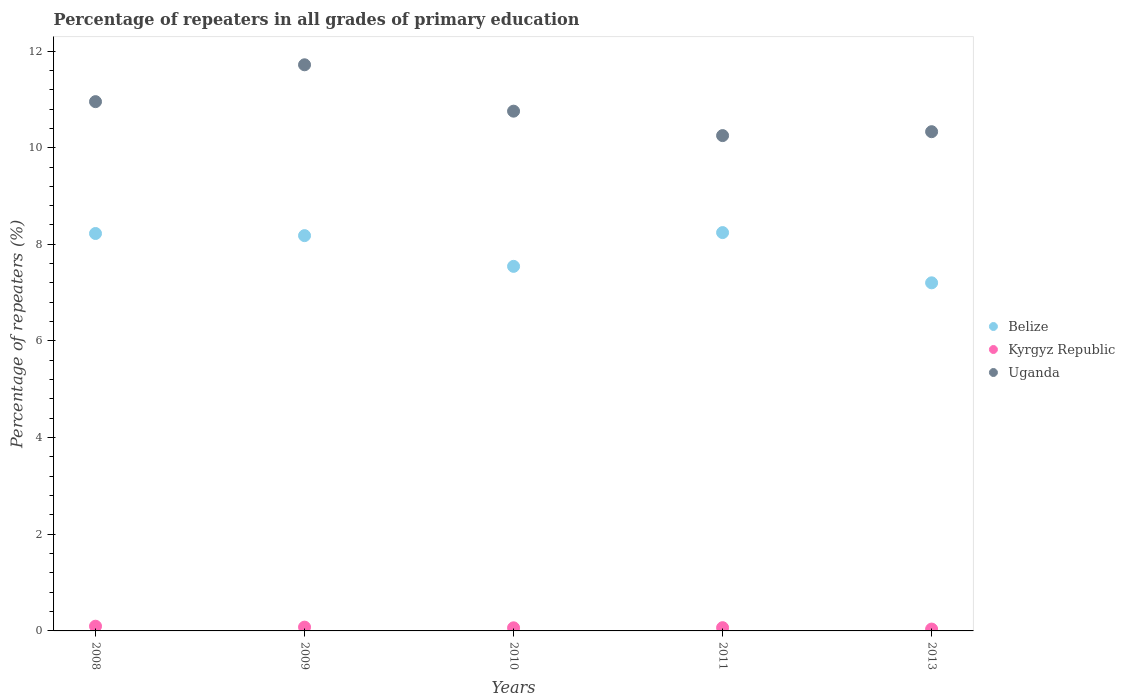How many different coloured dotlines are there?
Ensure brevity in your answer.  3. What is the percentage of repeaters in Belize in 2013?
Ensure brevity in your answer.  7.2. Across all years, what is the maximum percentage of repeaters in Kyrgyz Republic?
Your response must be concise. 0.1. Across all years, what is the minimum percentage of repeaters in Uganda?
Your answer should be very brief. 10.25. In which year was the percentage of repeaters in Belize minimum?
Your answer should be compact. 2013. What is the total percentage of repeaters in Kyrgyz Republic in the graph?
Give a very brief answer. 0.35. What is the difference between the percentage of repeaters in Uganda in 2008 and that in 2013?
Provide a succinct answer. 0.62. What is the difference between the percentage of repeaters in Belize in 2011 and the percentage of repeaters in Uganda in 2009?
Offer a very short reply. -3.47. What is the average percentage of repeaters in Uganda per year?
Offer a terse response. 10.8. In the year 2011, what is the difference between the percentage of repeaters in Belize and percentage of repeaters in Kyrgyz Republic?
Give a very brief answer. 8.18. In how many years, is the percentage of repeaters in Belize greater than 10 %?
Keep it short and to the point. 0. What is the ratio of the percentage of repeaters in Kyrgyz Republic in 2008 to that in 2009?
Ensure brevity in your answer.  1.24. What is the difference between the highest and the second highest percentage of repeaters in Kyrgyz Republic?
Provide a succinct answer. 0.02. What is the difference between the highest and the lowest percentage of repeaters in Kyrgyz Republic?
Your answer should be compact. 0.06. Does the percentage of repeaters in Kyrgyz Republic monotonically increase over the years?
Give a very brief answer. No. Is the percentage of repeaters in Uganda strictly less than the percentage of repeaters in Belize over the years?
Provide a succinct answer. No. How many dotlines are there?
Offer a very short reply. 3. How many years are there in the graph?
Provide a succinct answer. 5. What is the difference between two consecutive major ticks on the Y-axis?
Your answer should be compact. 2. Are the values on the major ticks of Y-axis written in scientific E-notation?
Give a very brief answer. No. Does the graph contain any zero values?
Ensure brevity in your answer.  No. Does the graph contain grids?
Ensure brevity in your answer.  No. How many legend labels are there?
Your answer should be very brief. 3. What is the title of the graph?
Make the answer very short. Percentage of repeaters in all grades of primary education. What is the label or title of the X-axis?
Your response must be concise. Years. What is the label or title of the Y-axis?
Ensure brevity in your answer.  Percentage of repeaters (%). What is the Percentage of repeaters (%) of Belize in 2008?
Provide a succinct answer. 8.22. What is the Percentage of repeaters (%) of Kyrgyz Republic in 2008?
Ensure brevity in your answer.  0.1. What is the Percentage of repeaters (%) in Uganda in 2008?
Your answer should be very brief. 10.95. What is the Percentage of repeaters (%) of Belize in 2009?
Give a very brief answer. 8.18. What is the Percentage of repeaters (%) in Kyrgyz Republic in 2009?
Offer a terse response. 0.08. What is the Percentage of repeaters (%) in Uganda in 2009?
Offer a very short reply. 11.72. What is the Percentage of repeaters (%) of Belize in 2010?
Ensure brevity in your answer.  7.54. What is the Percentage of repeaters (%) in Kyrgyz Republic in 2010?
Give a very brief answer. 0.06. What is the Percentage of repeaters (%) in Uganda in 2010?
Your answer should be very brief. 10.76. What is the Percentage of repeaters (%) of Belize in 2011?
Your response must be concise. 8.24. What is the Percentage of repeaters (%) in Kyrgyz Republic in 2011?
Make the answer very short. 0.07. What is the Percentage of repeaters (%) of Uganda in 2011?
Give a very brief answer. 10.25. What is the Percentage of repeaters (%) of Belize in 2013?
Make the answer very short. 7.2. What is the Percentage of repeaters (%) of Kyrgyz Republic in 2013?
Your response must be concise. 0.04. What is the Percentage of repeaters (%) in Uganda in 2013?
Make the answer very short. 10.33. Across all years, what is the maximum Percentage of repeaters (%) in Belize?
Offer a very short reply. 8.24. Across all years, what is the maximum Percentage of repeaters (%) in Kyrgyz Republic?
Your answer should be compact. 0.1. Across all years, what is the maximum Percentage of repeaters (%) in Uganda?
Provide a short and direct response. 11.72. Across all years, what is the minimum Percentage of repeaters (%) in Belize?
Provide a short and direct response. 7.2. Across all years, what is the minimum Percentage of repeaters (%) of Kyrgyz Republic?
Keep it short and to the point. 0.04. Across all years, what is the minimum Percentage of repeaters (%) of Uganda?
Give a very brief answer. 10.25. What is the total Percentage of repeaters (%) in Belize in the graph?
Provide a succinct answer. 39.39. What is the total Percentage of repeaters (%) of Kyrgyz Republic in the graph?
Offer a very short reply. 0.35. What is the total Percentage of repeaters (%) of Uganda in the graph?
Your response must be concise. 54. What is the difference between the Percentage of repeaters (%) of Belize in 2008 and that in 2009?
Your response must be concise. 0.04. What is the difference between the Percentage of repeaters (%) in Kyrgyz Republic in 2008 and that in 2009?
Keep it short and to the point. 0.02. What is the difference between the Percentage of repeaters (%) of Uganda in 2008 and that in 2009?
Your answer should be very brief. -0.76. What is the difference between the Percentage of repeaters (%) in Belize in 2008 and that in 2010?
Give a very brief answer. 0.68. What is the difference between the Percentage of repeaters (%) of Uganda in 2008 and that in 2010?
Provide a succinct answer. 0.2. What is the difference between the Percentage of repeaters (%) in Belize in 2008 and that in 2011?
Offer a terse response. -0.02. What is the difference between the Percentage of repeaters (%) in Kyrgyz Republic in 2008 and that in 2011?
Your answer should be compact. 0.03. What is the difference between the Percentage of repeaters (%) of Uganda in 2008 and that in 2011?
Your answer should be very brief. 0.7. What is the difference between the Percentage of repeaters (%) of Belize in 2008 and that in 2013?
Offer a terse response. 1.02. What is the difference between the Percentage of repeaters (%) in Kyrgyz Republic in 2008 and that in 2013?
Your answer should be compact. 0.06. What is the difference between the Percentage of repeaters (%) in Uganda in 2008 and that in 2013?
Your response must be concise. 0.62. What is the difference between the Percentage of repeaters (%) of Belize in 2009 and that in 2010?
Your answer should be compact. 0.64. What is the difference between the Percentage of repeaters (%) in Kyrgyz Republic in 2009 and that in 2010?
Offer a very short reply. 0.01. What is the difference between the Percentage of repeaters (%) of Uganda in 2009 and that in 2010?
Keep it short and to the point. 0.96. What is the difference between the Percentage of repeaters (%) in Belize in 2009 and that in 2011?
Offer a very short reply. -0.06. What is the difference between the Percentage of repeaters (%) of Kyrgyz Republic in 2009 and that in 2011?
Provide a succinct answer. 0.01. What is the difference between the Percentage of repeaters (%) in Uganda in 2009 and that in 2011?
Your response must be concise. 1.47. What is the difference between the Percentage of repeaters (%) in Belize in 2009 and that in 2013?
Your answer should be very brief. 0.98. What is the difference between the Percentage of repeaters (%) of Uganda in 2009 and that in 2013?
Offer a very short reply. 1.38. What is the difference between the Percentage of repeaters (%) in Belize in 2010 and that in 2011?
Your response must be concise. -0.7. What is the difference between the Percentage of repeaters (%) of Kyrgyz Republic in 2010 and that in 2011?
Your response must be concise. -0. What is the difference between the Percentage of repeaters (%) of Uganda in 2010 and that in 2011?
Provide a succinct answer. 0.51. What is the difference between the Percentage of repeaters (%) in Belize in 2010 and that in 2013?
Your answer should be very brief. 0.34. What is the difference between the Percentage of repeaters (%) of Kyrgyz Republic in 2010 and that in 2013?
Your response must be concise. 0.03. What is the difference between the Percentage of repeaters (%) of Uganda in 2010 and that in 2013?
Give a very brief answer. 0.42. What is the difference between the Percentage of repeaters (%) in Belize in 2011 and that in 2013?
Provide a succinct answer. 1.04. What is the difference between the Percentage of repeaters (%) in Kyrgyz Republic in 2011 and that in 2013?
Keep it short and to the point. 0.03. What is the difference between the Percentage of repeaters (%) of Uganda in 2011 and that in 2013?
Ensure brevity in your answer.  -0.08. What is the difference between the Percentage of repeaters (%) of Belize in 2008 and the Percentage of repeaters (%) of Kyrgyz Republic in 2009?
Ensure brevity in your answer.  8.15. What is the difference between the Percentage of repeaters (%) of Belize in 2008 and the Percentage of repeaters (%) of Uganda in 2009?
Provide a succinct answer. -3.49. What is the difference between the Percentage of repeaters (%) in Kyrgyz Republic in 2008 and the Percentage of repeaters (%) in Uganda in 2009?
Your response must be concise. -11.62. What is the difference between the Percentage of repeaters (%) in Belize in 2008 and the Percentage of repeaters (%) in Kyrgyz Republic in 2010?
Provide a succinct answer. 8.16. What is the difference between the Percentage of repeaters (%) in Belize in 2008 and the Percentage of repeaters (%) in Uganda in 2010?
Offer a very short reply. -2.53. What is the difference between the Percentage of repeaters (%) of Kyrgyz Republic in 2008 and the Percentage of repeaters (%) of Uganda in 2010?
Offer a terse response. -10.66. What is the difference between the Percentage of repeaters (%) in Belize in 2008 and the Percentage of repeaters (%) in Kyrgyz Republic in 2011?
Provide a succinct answer. 8.16. What is the difference between the Percentage of repeaters (%) in Belize in 2008 and the Percentage of repeaters (%) in Uganda in 2011?
Offer a very short reply. -2.03. What is the difference between the Percentage of repeaters (%) in Kyrgyz Republic in 2008 and the Percentage of repeaters (%) in Uganda in 2011?
Your answer should be very brief. -10.15. What is the difference between the Percentage of repeaters (%) of Belize in 2008 and the Percentage of repeaters (%) of Kyrgyz Republic in 2013?
Make the answer very short. 8.19. What is the difference between the Percentage of repeaters (%) of Belize in 2008 and the Percentage of repeaters (%) of Uganda in 2013?
Offer a terse response. -2.11. What is the difference between the Percentage of repeaters (%) in Kyrgyz Republic in 2008 and the Percentage of repeaters (%) in Uganda in 2013?
Make the answer very short. -10.23. What is the difference between the Percentage of repeaters (%) of Belize in 2009 and the Percentage of repeaters (%) of Kyrgyz Republic in 2010?
Make the answer very short. 8.12. What is the difference between the Percentage of repeaters (%) in Belize in 2009 and the Percentage of repeaters (%) in Uganda in 2010?
Ensure brevity in your answer.  -2.58. What is the difference between the Percentage of repeaters (%) in Kyrgyz Republic in 2009 and the Percentage of repeaters (%) in Uganda in 2010?
Make the answer very short. -10.68. What is the difference between the Percentage of repeaters (%) in Belize in 2009 and the Percentage of repeaters (%) in Kyrgyz Republic in 2011?
Your response must be concise. 8.11. What is the difference between the Percentage of repeaters (%) in Belize in 2009 and the Percentage of repeaters (%) in Uganda in 2011?
Make the answer very short. -2.07. What is the difference between the Percentage of repeaters (%) in Kyrgyz Republic in 2009 and the Percentage of repeaters (%) in Uganda in 2011?
Offer a very short reply. -10.17. What is the difference between the Percentage of repeaters (%) in Belize in 2009 and the Percentage of repeaters (%) in Kyrgyz Republic in 2013?
Your response must be concise. 8.14. What is the difference between the Percentage of repeaters (%) of Belize in 2009 and the Percentage of repeaters (%) of Uganda in 2013?
Your answer should be very brief. -2.15. What is the difference between the Percentage of repeaters (%) of Kyrgyz Republic in 2009 and the Percentage of repeaters (%) of Uganda in 2013?
Your response must be concise. -10.25. What is the difference between the Percentage of repeaters (%) in Belize in 2010 and the Percentage of repeaters (%) in Kyrgyz Republic in 2011?
Your answer should be compact. 7.48. What is the difference between the Percentage of repeaters (%) of Belize in 2010 and the Percentage of repeaters (%) of Uganda in 2011?
Give a very brief answer. -2.71. What is the difference between the Percentage of repeaters (%) of Kyrgyz Republic in 2010 and the Percentage of repeaters (%) of Uganda in 2011?
Offer a terse response. -10.19. What is the difference between the Percentage of repeaters (%) of Belize in 2010 and the Percentage of repeaters (%) of Kyrgyz Republic in 2013?
Give a very brief answer. 7.51. What is the difference between the Percentage of repeaters (%) in Belize in 2010 and the Percentage of repeaters (%) in Uganda in 2013?
Provide a short and direct response. -2.79. What is the difference between the Percentage of repeaters (%) in Kyrgyz Republic in 2010 and the Percentage of repeaters (%) in Uganda in 2013?
Your answer should be compact. -10.27. What is the difference between the Percentage of repeaters (%) of Belize in 2011 and the Percentage of repeaters (%) of Kyrgyz Republic in 2013?
Your response must be concise. 8.2. What is the difference between the Percentage of repeaters (%) of Belize in 2011 and the Percentage of repeaters (%) of Uganda in 2013?
Offer a terse response. -2.09. What is the difference between the Percentage of repeaters (%) of Kyrgyz Republic in 2011 and the Percentage of repeaters (%) of Uganda in 2013?
Your answer should be compact. -10.26. What is the average Percentage of repeaters (%) in Belize per year?
Keep it short and to the point. 7.88. What is the average Percentage of repeaters (%) of Kyrgyz Republic per year?
Provide a short and direct response. 0.07. What is the average Percentage of repeaters (%) in Uganda per year?
Offer a terse response. 10.8. In the year 2008, what is the difference between the Percentage of repeaters (%) of Belize and Percentage of repeaters (%) of Kyrgyz Republic?
Offer a very short reply. 8.13. In the year 2008, what is the difference between the Percentage of repeaters (%) in Belize and Percentage of repeaters (%) in Uganda?
Provide a short and direct response. -2.73. In the year 2008, what is the difference between the Percentage of repeaters (%) in Kyrgyz Republic and Percentage of repeaters (%) in Uganda?
Your answer should be compact. -10.86. In the year 2009, what is the difference between the Percentage of repeaters (%) of Belize and Percentage of repeaters (%) of Kyrgyz Republic?
Offer a very short reply. 8.1. In the year 2009, what is the difference between the Percentage of repeaters (%) of Belize and Percentage of repeaters (%) of Uganda?
Keep it short and to the point. -3.54. In the year 2009, what is the difference between the Percentage of repeaters (%) of Kyrgyz Republic and Percentage of repeaters (%) of Uganda?
Ensure brevity in your answer.  -11.64. In the year 2010, what is the difference between the Percentage of repeaters (%) in Belize and Percentage of repeaters (%) in Kyrgyz Republic?
Your answer should be very brief. 7.48. In the year 2010, what is the difference between the Percentage of repeaters (%) in Belize and Percentage of repeaters (%) in Uganda?
Your response must be concise. -3.21. In the year 2010, what is the difference between the Percentage of repeaters (%) in Kyrgyz Republic and Percentage of repeaters (%) in Uganda?
Make the answer very short. -10.69. In the year 2011, what is the difference between the Percentage of repeaters (%) of Belize and Percentage of repeaters (%) of Kyrgyz Republic?
Your answer should be very brief. 8.18. In the year 2011, what is the difference between the Percentage of repeaters (%) of Belize and Percentage of repeaters (%) of Uganda?
Ensure brevity in your answer.  -2.01. In the year 2011, what is the difference between the Percentage of repeaters (%) in Kyrgyz Republic and Percentage of repeaters (%) in Uganda?
Give a very brief answer. -10.18. In the year 2013, what is the difference between the Percentage of repeaters (%) of Belize and Percentage of repeaters (%) of Kyrgyz Republic?
Your answer should be compact. 7.16. In the year 2013, what is the difference between the Percentage of repeaters (%) of Belize and Percentage of repeaters (%) of Uganda?
Offer a very short reply. -3.13. In the year 2013, what is the difference between the Percentage of repeaters (%) of Kyrgyz Republic and Percentage of repeaters (%) of Uganda?
Make the answer very short. -10.29. What is the ratio of the Percentage of repeaters (%) of Belize in 2008 to that in 2009?
Provide a short and direct response. 1.01. What is the ratio of the Percentage of repeaters (%) in Kyrgyz Republic in 2008 to that in 2009?
Ensure brevity in your answer.  1.24. What is the ratio of the Percentage of repeaters (%) of Uganda in 2008 to that in 2009?
Your answer should be very brief. 0.93. What is the ratio of the Percentage of repeaters (%) in Belize in 2008 to that in 2010?
Provide a short and direct response. 1.09. What is the ratio of the Percentage of repeaters (%) in Kyrgyz Republic in 2008 to that in 2010?
Provide a short and direct response. 1.52. What is the ratio of the Percentage of repeaters (%) in Uganda in 2008 to that in 2010?
Provide a short and direct response. 1.02. What is the ratio of the Percentage of repeaters (%) in Belize in 2008 to that in 2011?
Keep it short and to the point. 1. What is the ratio of the Percentage of repeaters (%) of Kyrgyz Republic in 2008 to that in 2011?
Make the answer very short. 1.46. What is the ratio of the Percentage of repeaters (%) of Uganda in 2008 to that in 2011?
Offer a very short reply. 1.07. What is the ratio of the Percentage of repeaters (%) of Belize in 2008 to that in 2013?
Provide a succinct answer. 1.14. What is the ratio of the Percentage of repeaters (%) in Kyrgyz Republic in 2008 to that in 2013?
Your answer should be very brief. 2.54. What is the ratio of the Percentage of repeaters (%) of Uganda in 2008 to that in 2013?
Provide a short and direct response. 1.06. What is the ratio of the Percentage of repeaters (%) in Belize in 2009 to that in 2010?
Your answer should be very brief. 1.08. What is the ratio of the Percentage of repeaters (%) of Kyrgyz Republic in 2009 to that in 2010?
Provide a short and direct response. 1.22. What is the ratio of the Percentage of repeaters (%) in Uganda in 2009 to that in 2010?
Your answer should be very brief. 1.09. What is the ratio of the Percentage of repeaters (%) of Belize in 2009 to that in 2011?
Your response must be concise. 0.99. What is the ratio of the Percentage of repeaters (%) of Kyrgyz Republic in 2009 to that in 2011?
Keep it short and to the point. 1.17. What is the ratio of the Percentage of repeaters (%) of Uganda in 2009 to that in 2011?
Keep it short and to the point. 1.14. What is the ratio of the Percentage of repeaters (%) of Belize in 2009 to that in 2013?
Provide a short and direct response. 1.14. What is the ratio of the Percentage of repeaters (%) in Kyrgyz Republic in 2009 to that in 2013?
Your response must be concise. 2.04. What is the ratio of the Percentage of repeaters (%) in Uganda in 2009 to that in 2013?
Provide a short and direct response. 1.13. What is the ratio of the Percentage of repeaters (%) of Belize in 2010 to that in 2011?
Keep it short and to the point. 0.92. What is the ratio of the Percentage of repeaters (%) in Kyrgyz Republic in 2010 to that in 2011?
Offer a terse response. 0.96. What is the ratio of the Percentage of repeaters (%) in Uganda in 2010 to that in 2011?
Give a very brief answer. 1.05. What is the ratio of the Percentage of repeaters (%) in Belize in 2010 to that in 2013?
Give a very brief answer. 1.05. What is the ratio of the Percentage of repeaters (%) in Kyrgyz Republic in 2010 to that in 2013?
Ensure brevity in your answer.  1.67. What is the ratio of the Percentage of repeaters (%) of Uganda in 2010 to that in 2013?
Your response must be concise. 1.04. What is the ratio of the Percentage of repeaters (%) in Belize in 2011 to that in 2013?
Offer a terse response. 1.14. What is the ratio of the Percentage of repeaters (%) in Kyrgyz Republic in 2011 to that in 2013?
Your response must be concise. 1.74. What is the difference between the highest and the second highest Percentage of repeaters (%) in Belize?
Ensure brevity in your answer.  0.02. What is the difference between the highest and the second highest Percentage of repeaters (%) in Kyrgyz Republic?
Offer a very short reply. 0.02. What is the difference between the highest and the second highest Percentage of repeaters (%) in Uganda?
Keep it short and to the point. 0.76. What is the difference between the highest and the lowest Percentage of repeaters (%) in Belize?
Your answer should be very brief. 1.04. What is the difference between the highest and the lowest Percentage of repeaters (%) of Kyrgyz Republic?
Provide a short and direct response. 0.06. What is the difference between the highest and the lowest Percentage of repeaters (%) in Uganda?
Provide a succinct answer. 1.47. 